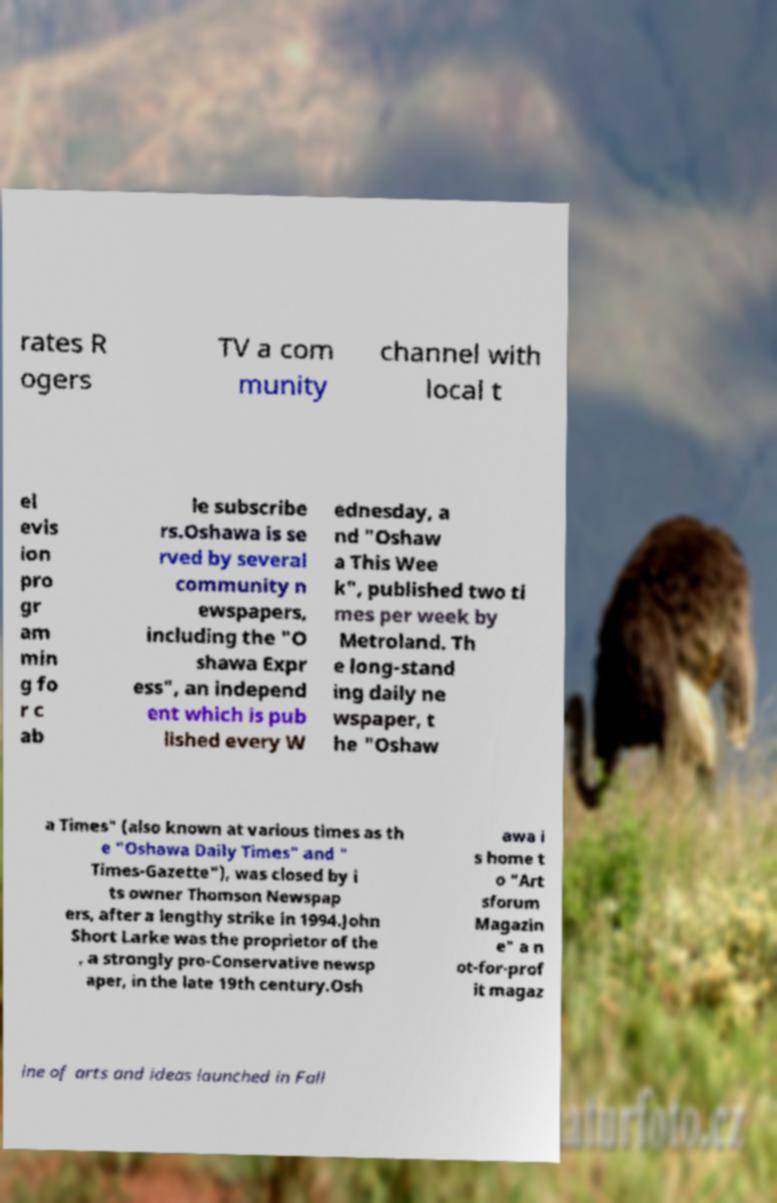There's text embedded in this image that I need extracted. Can you transcribe it verbatim? rates R ogers TV a com munity channel with local t el evis ion pro gr am min g fo r c ab le subscribe rs.Oshawa is se rved by several community n ewspapers, including the "O shawa Expr ess", an independ ent which is pub lished every W ednesday, a nd "Oshaw a This Wee k", published two ti mes per week by Metroland. Th e long-stand ing daily ne wspaper, t he "Oshaw a Times" (also known at various times as th e "Oshawa Daily Times" and " Times-Gazette"), was closed by i ts owner Thomson Newspap ers, after a lengthy strike in 1994.John Short Larke was the proprietor of the , a strongly pro-Conservative newsp aper, in the late 19th century.Osh awa i s home t o "Art sforum Magazin e" a n ot-for-prof it magaz ine of arts and ideas launched in Fall 